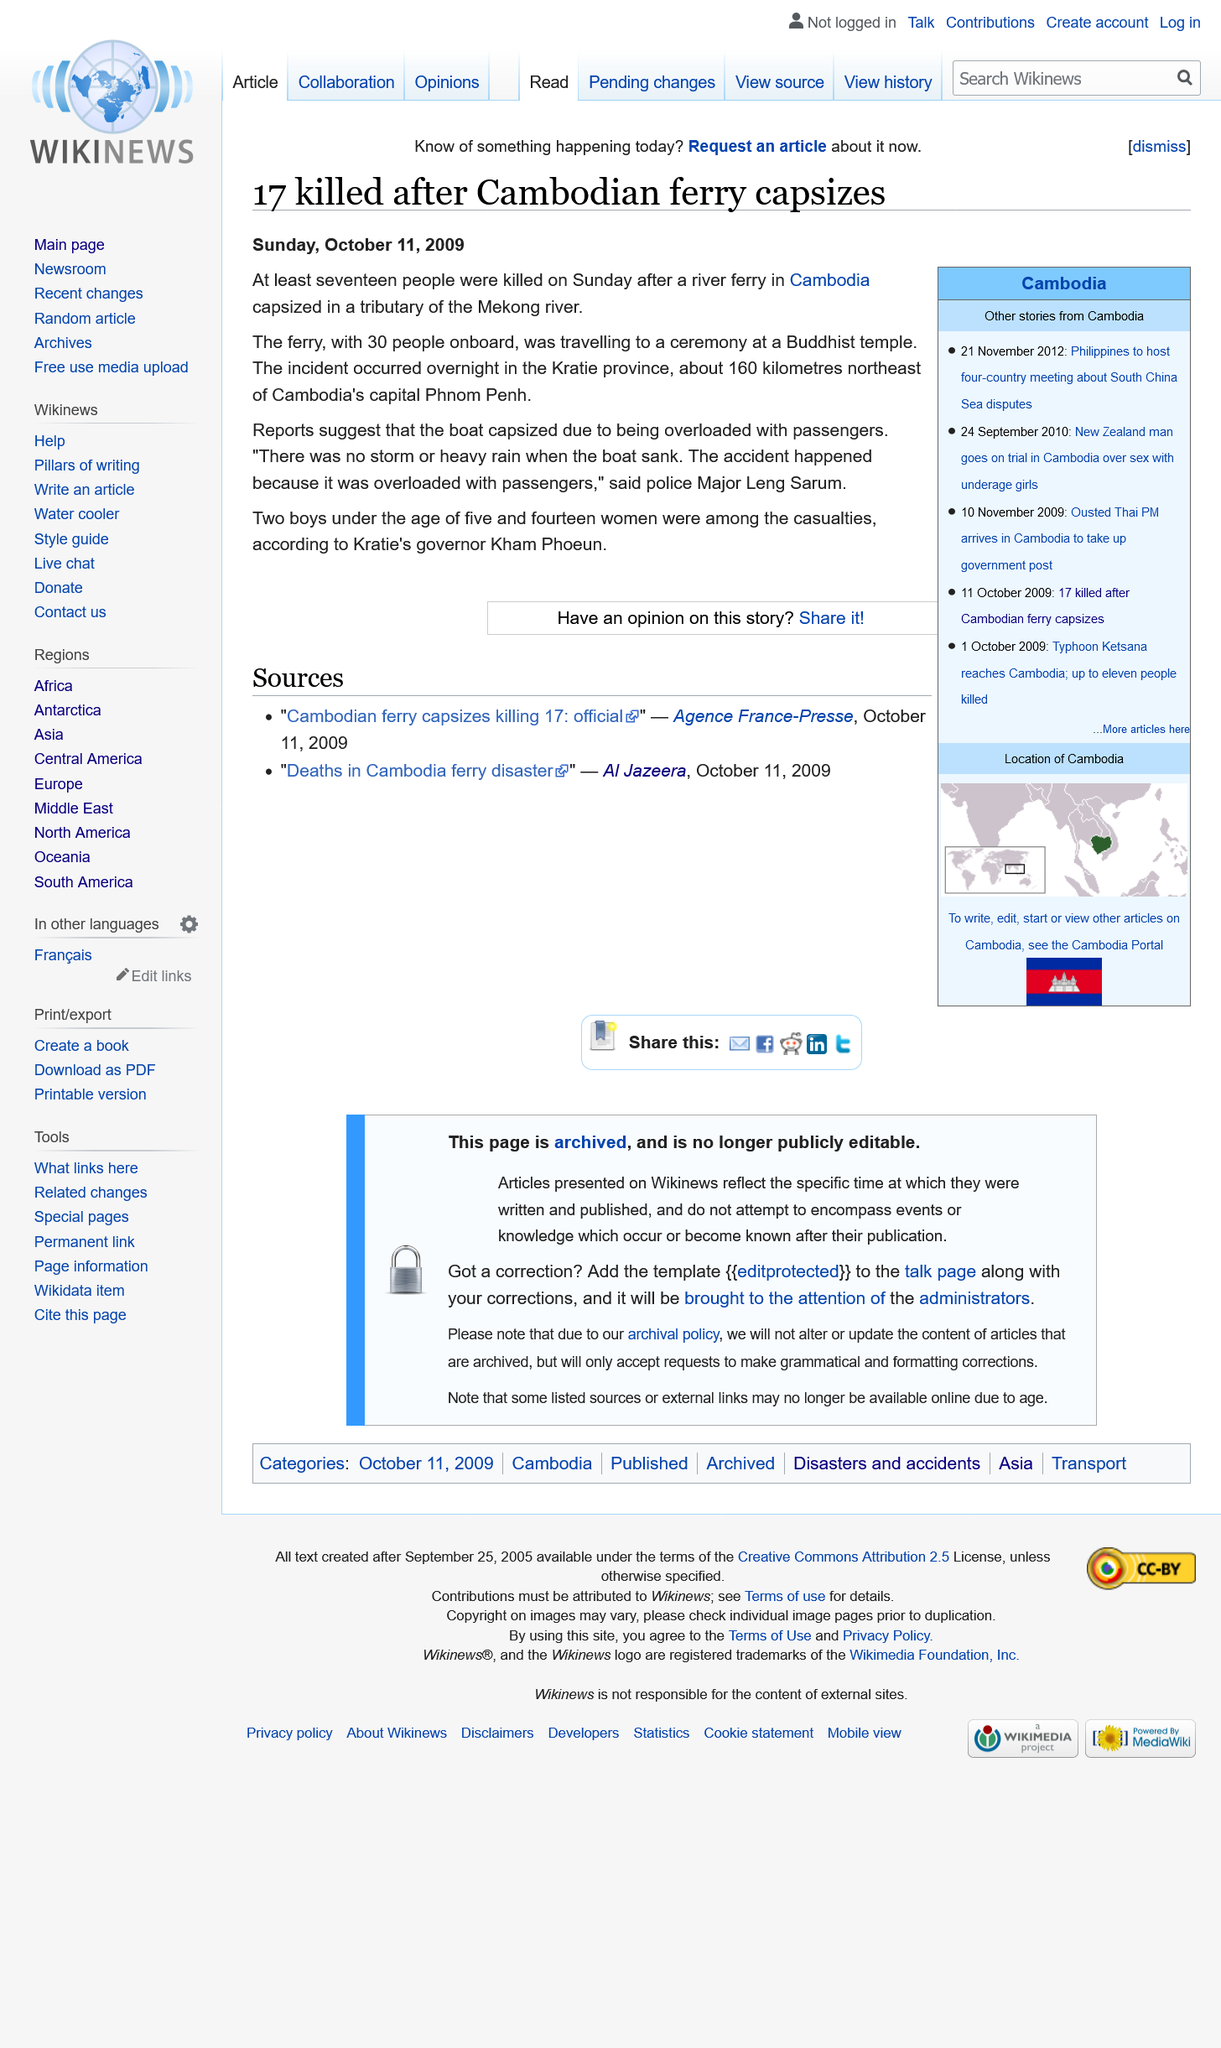Point out several critical features in this image. In 2009, Kratie's governor was Kham Phoeun. On October 2009, a river ferry capsized in Cambodia, resulting in the death of at least 17 people. The capital city of Cambodia is Phnom Penh, which is located in the country's southeastern region. Phnom Penh is Cambodia's largest city and is known for its historic landmarks, cultural attractions, and vibrant street life. The city is home to the Royal Palace, the Silver Pagoda, and the National Museum, which are all popular tourist destinations. Phnom Penh is also a hub for the country's government, business, and cultural activities. 